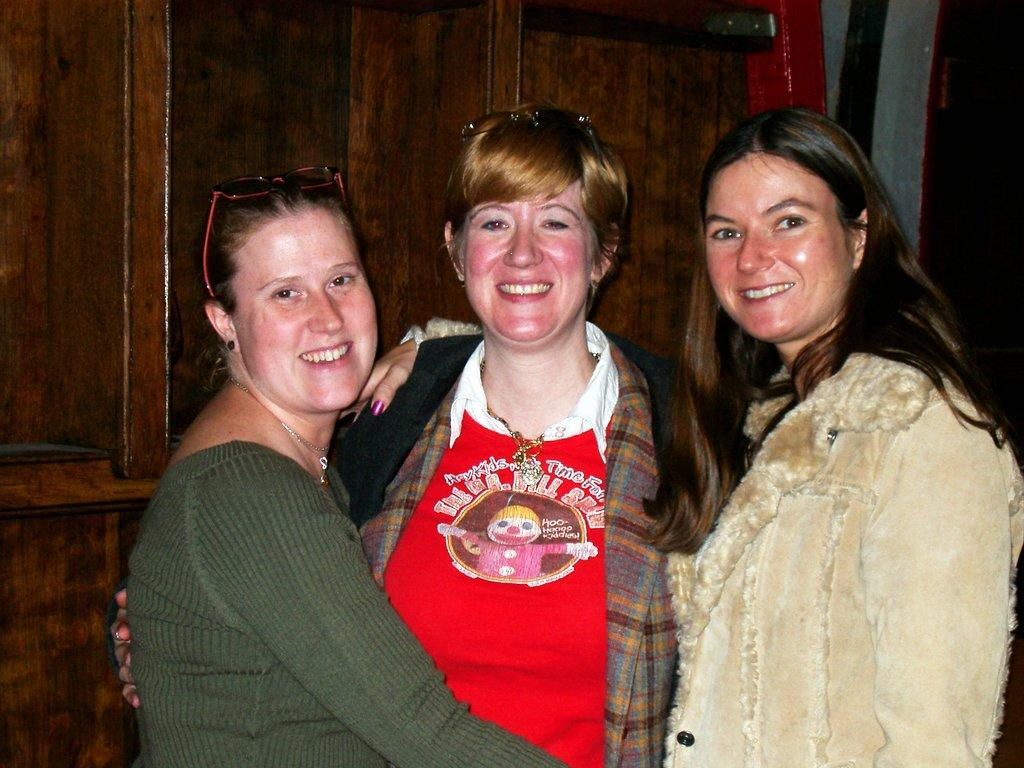What are the people in the image doing? The people in the image are standing and smiling. What can be seen in the background of the image? There is a wall and objects visible in the background of the image. What type of treatment is being administered to the family in the image? There is no family present in the image, and no treatment is being administered. Can you see any twigs in the image? There is no mention of twigs in the provided facts, and they are not visible in the image. 